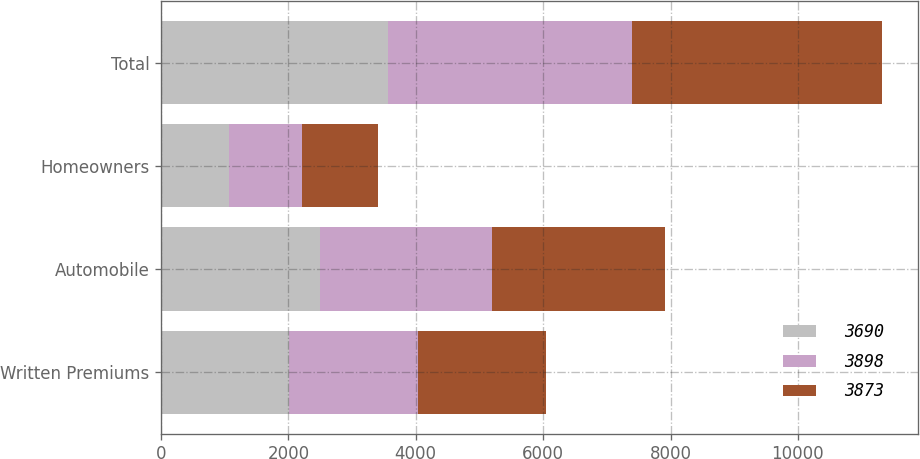Convert chart to OTSL. <chart><loc_0><loc_0><loc_500><loc_500><stacked_bar_chart><ecel><fcel>Written Premiums<fcel>Automobile<fcel>Homeowners<fcel>Total<nl><fcel>3690<fcel>2017<fcel>2497<fcel>1064<fcel>3561<nl><fcel>3898<fcel>2016<fcel>2694<fcel>1143<fcel>3837<nl><fcel>3873<fcel>2015<fcel>2721<fcel>1197<fcel>3918<nl></chart> 